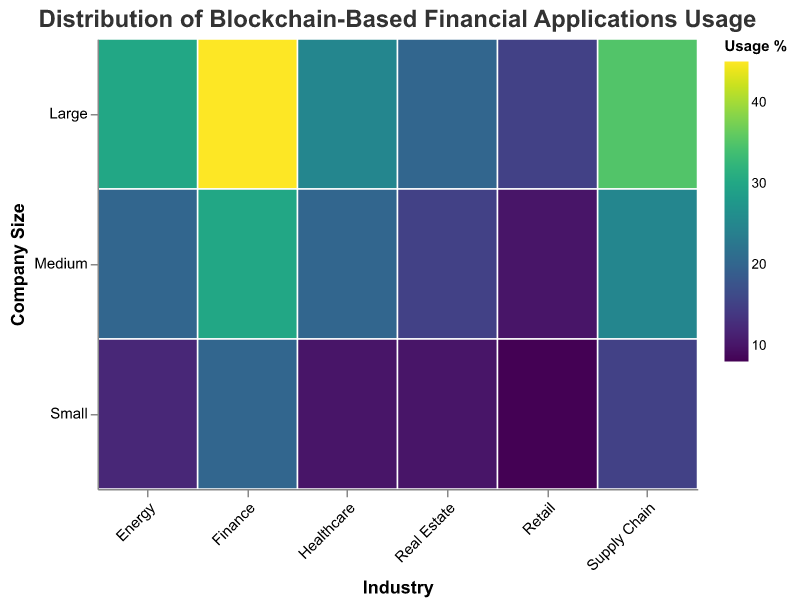Which industry has the highest large company usage percentage? The figure shows the usage percentages with different colors. The Finance industry has the darkest shade in the "Large" row, indicating the highest usage percentage.
Answer: Finance Which industry has the lowest small company usage percentage? By looking at the colors in the "Small" row, the lightest shade corresponds to the Retail industry.
Answer: Retail What's the difference in usage percentage between large and small companies in the Energy sector? The usage percentages for the Energy sector are 30% for large companies and 12% for small companies. The difference is calculated as 30 - 12.
Answer: 18 Which two industries have the closest usage percentage for medium-sized companies? By comparing the colors and values in the "Medium" row, Healthcare and Energy both show a 20% usage percentage, indicating they have the closest values.
Answer: Healthcare and Energy What is the combined usage percentage of all company sizes in the Supply Chain industry? Summing the usage percentages for the Supply Chain industry: 35% (large) + 25% (medium) + 15% (small) = 75%.
Answer: 75% How does the usage percentage for large companies in Healthcare compare to that in Finance? The usage percentage for large companies in Healthcare is 25%, while in Finance, it is 45%. Since 25% is less than 45%, Healthcare has a lower usage percentage.
Answer: Less Which industry has the most evenly distributed usage percentages across company sizes? The Real Estate industry has percentages of 20% (large), 15% (medium), and 10% (small), which are relatively close to each other compared to other industries.
Answer: Real Estate Is there any company size that consistently has the highest usage percentage across all industries? Checking each row, large companies consistently have higher or equal usage percentages in every industry compared to medium and small.
Answer: Yes What's the average usage percentage for small companies across all industries? Summing the small company usage percentages for all industries: 20% (Finance) + 10% (Healthcare) + 15% (Supply Chain) + 10% (Real Estate) + 12% (Energy) + 8% (Retail) = 75%. Dividing by the number of industries (6): 75% / 6 = 12.5%.
Answer: 12.5% Which industries have a medium company usage percentage lower than 25%? The Healthcare (20%), Real Estate (15%), Energy (20%), and Retail (10%) industries all have medium company usage percentages below 25%.
Answer: Healthcare, Real Estate, Energy, and Retail 